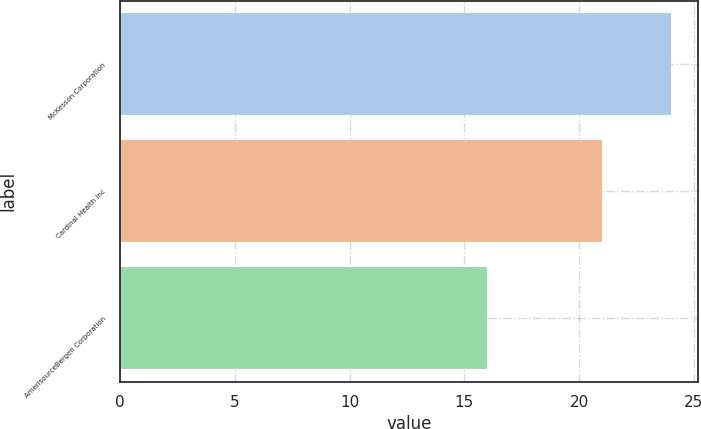Convert chart. <chart><loc_0><loc_0><loc_500><loc_500><bar_chart><fcel>McKesson Corporation<fcel>Cardinal Health Inc<fcel>AmerisourceBergen Corporation<nl><fcel>24<fcel>21<fcel>16<nl></chart> 